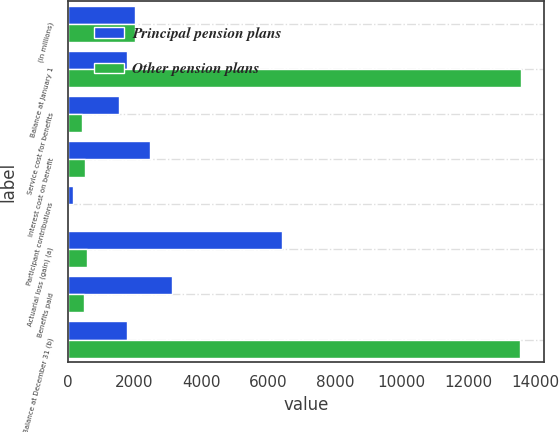<chart> <loc_0><loc_0><loc_500><loc_500><stacked_bar_chart><ecel><fcel>(In millions)<fcel>Balance at January 1<fcel>Service cost for benefits<fcel>Interest cost on benefit<fcel>Participant contributions<fcel>Actuarial loss (gain) (a)<fcel>Benefits paid<fcel>Balance at December 31 (b)<nl><fcel>Principal pension plans<fcel>2013<fcel>1774<fcel>1535<fcel>2460<fcel>156<fcel>6406<fcel>3134<fcel>1774<nl><fcel>Other pension plans<fcel>2013<fcel>13584<fcel>435<fcel>523<fcel>14<fcel>575<fcel>477<fcel>13535<nl></chart> 